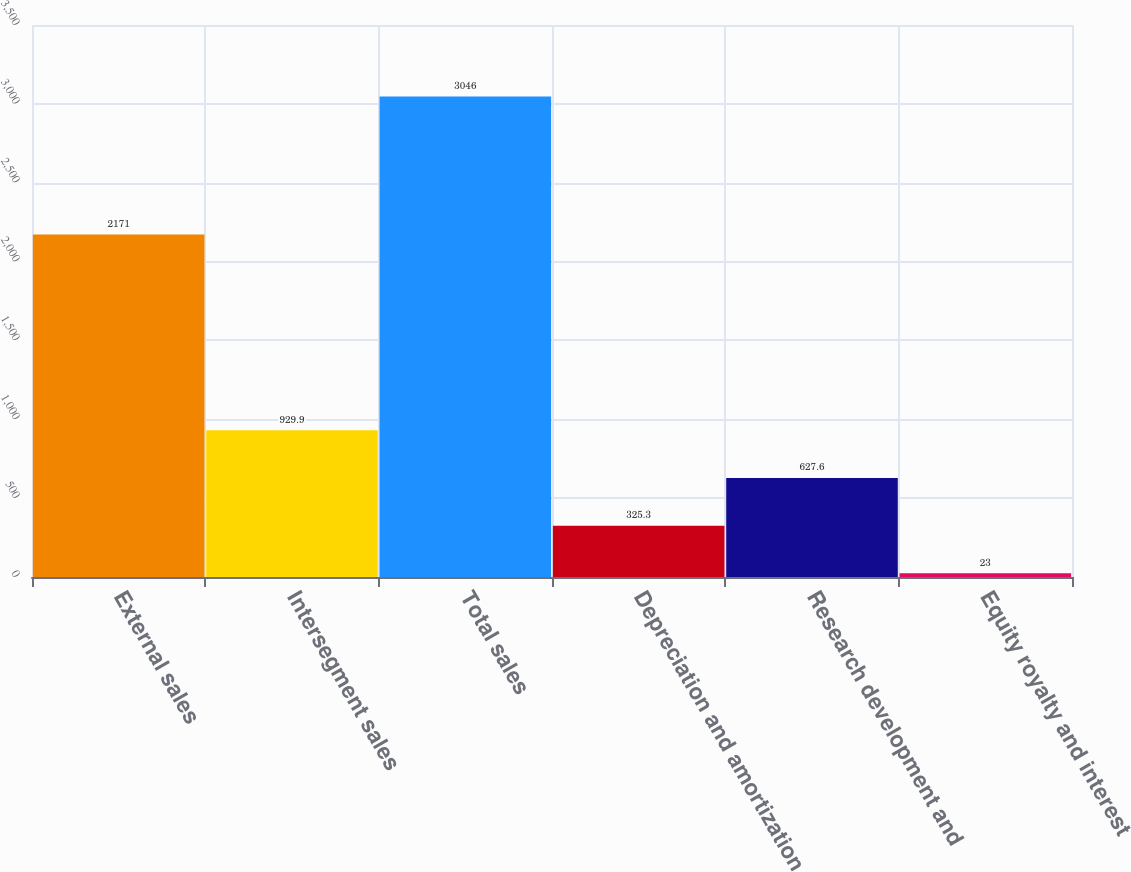<chart> <loc_0><loc_0><loc_500><loc_500><bar_chart><fcel>External sales<fcel>Intersegment sales<fcel>Total sales<fcel>Depreciation and amortization<fcel>Research development and<fcel>Equity royalty and interest<nl><fcel>2171<fcel>929.9<fcel>3046<fcel>325.3<fcel>627.6<fcel>23<nl></chart> 